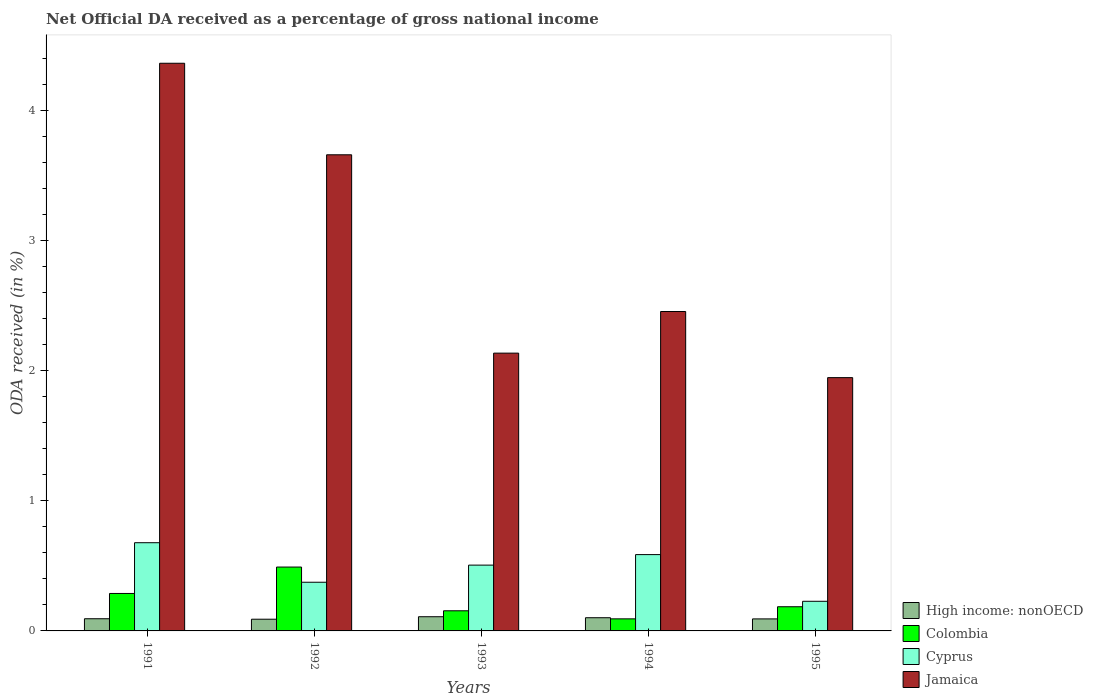How many groups of bars are there?
Ensure brevity in your answer.  5. Are the number of bars on each tick of the X-axis equal?
Your response must be concise. Yes. What is the label of the 5th group of bars from the left?
Your answer should be compact. 1995. What is the net official DA received in Colombia in 1992?
Provide a short and direct response. 0.49. Across all years, what is the maximum net official DA received in Jamaica?
Give a very brief answer. 4.36. Across all years, what is the minimum net official DA received in Colombia?
Your answer should be compact. 0.09. In which year was the net official DA received in Cyprus maximum?
Provide a succinct answer. 1991. What is the total net official DA received in Cyprus in the graph?
Your answer should be very brief. 2.37. What is the difference between the net official DA received in Colombia in 1992 and that in 1993?
Offer a very short reply. 0.34. What is the difference between the net official DA received in High income: nonOECD in 1992 and the net official DA received in Cyprus in 1995?
Your response must be concise. -0.14. What is the average net official DA received in Colombia per year?
Ensure brevity in your answer.  0.24. In the year 1992, what is the difference between the net official DA received in Cyprus and net official DA received in Colombia?
Offer a terse response. -0.12. In how many years, is the net official DA received in High income: nonOECD greater than 3.4 %?
Offer a terse response. 0. What is the ratio of the net official DA received in Colombia in 1992 to that in 1994?
Your response must be concise. 5.29. What is the difference between the highest and the second highest net official DA received in High income: nonOECD?
Offer a terse response. 0.01. What is the difference between the highest and the lowest net official DA received in High income: nonOECD?
Give a very brief answer. 0.02. In how many years, is the net official DA received in High income: nonOECD greater than the average net official DA received in High income: nonOECD taken over all years?
Offer a terse response. 2. Is the sum of the net official DA received in Colombia in 1993 and 1994 greater than the maximum net official DA received in Jamaica across all years?
Your response must be concise. No. What does the 2nd bar from the left in 1995 represents?
Make the answer very short. Colombia. What does the 3rd bar from the right in 1993 represents?
Give a very brief answer. Colombia. Is it the case that in every year, the sum of the net official DA received in Cyprus and net official DA received in Jamaica is greater than the net official DA received in High income: nonOECD?
Give a very brief answer. Yes. How many bars are there?
Ensure brevity in your answer.  20. Are all the bars in the graph horizontal?
Your response must be concise. No. What is the difference between two consecutive major ticks on the Y-axis?
Your response must be concise. 1. Are the values on the major ticks of Y-axis written in scientific E-notation?
Your answer should be very brief. No. How many legend labels are there?
Offer a very short reply. 4. What is the title of the graph?
Your response must be concise. Net Official DA received as a percentage of gross national income. Does "European Union" appear as one of the legend labels in the graph?
Give a very brief answer. No. What is the label or title of the Y-axis?
Your response must be concise. ODA received (in %). What is the ODA received (in %) in High income: nonOECD in 1991?
Your response must be concise. 0.09. What is the ODA received (in %) in Colombia in 1991?
Your response must be concise. 0.29. What is the ODA received (in %) in Cyprus in 1991?
Provide a short and direct response. 0.68. What is the ODA received (in %) of Jamaica in 1991?
Ensure brevity in your answer.  4.36. What is the ODA received (in %) in High income: nonOECD in 1992?
Provide a succinct answer. 0.09. What is the ODA received (in %) of Colombia in 1992?
Provide a succinct answer. 0.49. What is the ODA received (in %) in Cyprus in 1992?
Give a very brief answer. 0.37. What is the ODA received (in %) of Jamaica in 1992?
Keep it short and to the point. 3.66. What is the ODA received (in %) of High income: nonOECD in 1993?
Offer a terse response. 0.11. What is the ODA received (in %) of Colombia in 1993?
Give a very brief answer. 0.15. What is the ODA received (in %) of Cyprus in 1993?
Provide a short and direct response. 0.51. What is the ODA received (in %) in Jamaica in 1993?
Make the answer very short. 2.13. What is the ODA received (in %) of High income: nonOECD in 1994?
Provide a short and direct response. 0.1. What is the ODA received (in %) of Colombia in 1994?
Offer a terse response. 0.09. What is the ODA received (in %) of Cyprus in 1994?
Offer a very short reply. 0.59. What is the ODA received (in %) in Jamaica in 1994?
Your response must be concise. 2.45. What is the ODA received (in %) in High income: nonOECD in 1995?
Your answer should be very brief. 0.09. What is the ODA received (in %) in Colombia in 1995?
Give a very brief answer. 0.19. What is the ODA received (in %) in Cyprus in 1995?
Your answer should be very brief. 0.23. What is the ODA received (in %) in Jamaica in 1995?
Ensure brevity in your answer.  1.95. Across all years, what is the maximum ODA received (in %) of High income: nonOECD?
Offer a terse response. 0.11. Across all years, what is the maximum ODA received (in %) in Colombia?
Provide a succinct answer. 0.49. Across all years, what is the maximum ODA received (in %) of Cyprus?
Your answer should be compact. 0.68. Across all years, what is the maximum ODA received (in %) in Jamaica?
Offer a very short reply. 4.36. Across all years, what is the minimum ODA received (in %) in High income: nonOECD?
Your answer should be compact. 0.09. Across all years, what is the minimum ODA received (in %) of Colombia?
Offer a terse response. 0.09. Across all years, what is the minimum ODA received (in %) of Cyprus?
Your answer should be compact. 0.23. Across all years, what is the minimum ODA received (in %) of Jamaica?
Ensure brevity in your answer.  1.95. What is the total ODA received (in %) in High income: nonOECD in the graph?
Provide a short and direct response. 0.49. What is the total ODA received (in %) in Colombia in the graph?
Offer a very short reply. 1.21. What is the total ODA received (in %) of Cyprus in the graph?
Your answer should be compact. 2.37. What is the total ODA received (in %) in Jamaica in the graph?
Offer a terse response. 14.55. What is the difference between the ODA received (in %) in High income: nonOECD in 1991 and that in 1992?
Ensure brevity in your answer.  0. What is the difference between the ODA received (in %) of Colombia in 1991 and that in 1992?
Give a very brief answer. -0.2. What is the difference between the ODA received (in %) of Cyprus in 1991 and that in 1992?
Give a very brief answer. 0.3. What is the difference between the ODA received (in %) in Jamaica in 1991 and that in 1992?
Your answer should be very brief. 0.7. What is the difference between the ODA received (in %) in High income: nonOECD in 1991 and that in 1993?
Offer a terse response. -0.02. What is the difference between the ODA received (in %) of Colombia in 1991 and that in 1993?
Make the answer very short. 0.13. What is the difference between the ODA received (in %) of Cyprus in 1991 and that in 1993?
Provide a short and direct response. 0.17. What is the difference between the ODA received (in %) in Jamaica in 1991 and that in 1993?
Provide a short and direct response. 2.23. What is the difference between the ODA received (in %) in High income: nonOECD in 1991 and that in 1994?
Give a very brief answer. -0.01. What is the difference between the ODA received (in %) in Colombia in 1991 and that in 1994?
Offer a very short reply. 0.2. What is the difference between the ODA received (in %) of Cyprus in 1991 and that in 1994?
Provide a short and direct response. 0.09. What is the difference between the ODA received (in %) in Jamaica in 1991 and that in 1994?
Make the answer very short. 1.91. What is the difference between the ODA received (in %) in High income: nonOECD in 1991 and that in 1995?
Keep it short and to the point. 0. What is the difference between the ODA received (in %) in Colombia in 1991 and that in 1995?
Make the answer very short. 0.1. What is the difference between the ODA received (in %) in Cyprus in 1991 and that in 1995?
Give a very brief answer. 0.45. What is the difference between the ODA received (in %) in Jamaica in 1991 and that in 1995?
Your answer should be very brief. 2.42. What is the difference between the ODA received (in %) in High income: nonOECD in 1992 and that in 1993?
Provide a short and direct response. -0.02. What is the difference between the ODA received (in %) of Colombia in 1992 and that in 1993?
Provide a succinct answer. 0.34. What is the difference between the ODA received (in %) of Cyprus in 1992 and that in 1993?
Your answer should be very brief. -0.13. What is the difference between the ODA received (in %) of Jamaica in 1992 and that in 1993?
Your response must be concise. 1.52. What is the difference between the ODA received (in %) in High income: nonOECD in 1992 and that in 1994?
Ensure brevity in your answer.  -0.01. What is the difference between the ODA received (in %) in Colombia in 1992 and that in 1994?
Your answer should be very brief. 0.4. What is the difference between the ODA received (in %) of Cyprus in 1992 and that in 1994?
Your response must be concise. -0.21. What is the difference between the ODA received (in %) in Jamaica in 1992 and that in 1994?
Make the answer very short. 1.2. What is the difference between the ODA received (in %) of High income: nonOECD in 1992 and that in 1995?
Ensure brevity in your answer.  -0. What is the difference between the ODA received (in %) of Colombia in 1992 and that in 1995?
Your response must be concise. 0.3. What is the difference between the ODA received (in %) of Cyprus in 1992 and that in 1995?
Offer a terse response. 0.15. What is the difference between the ODA received (in %) of Jamaica in 1992 and that in 1995?
Keep it short and to the point. 1.71. What is the difference between the ODA received (in %) in High income: nonOECD in 1993 and that in 1994?
Offer a very short reply. 0.01. What is the difference between the ODA received (in %) of Colombia in 1993 and that in 1994?
Your response must be concise. 0.06. What is the difference between the ODA received (in %) in Cyprus in 1993 and that in 1994?
Offer a terse response. -0.08. What is the difference between the ODA received (in %) of Jamaica in 1993 and that in 1994?
Provide a short and direct response. -0.32. What is the difference between the ODA received (in %) in High income: nonOECD in 1993 and that in 1995?
Offer a terse response. 0.02. What is the difference between the ODA received (in %) of Colombia in 1993 and that in 1995?
Your answer should be very brief. -0.03. What is the difference between the ODA received (in %) in Cyprus in 1993 and that in 1995?
Provide a short and direct response. 0.28. What is the difference between the ODA received (in %) of Jamaica in 1993 and that in 1995?
Give a very brief answer. 0.19. What is the difference between the ODA received (in %) of High income: nonOECD in 1994 and that in 1995?
Make the answer very short. 0.01. What is the difference between the ODA received (in %) of Colombia in 1994 and that in 1995?
Provide a short and direct response. -0.09. What is the difference between the ODA received (in %) in Cyprus in 1994 and that in 1995?
Your response must be concise. 0.36. What is the difference between the ODA received (in %) in Jamaica in 1994 and that in 1995?
Your answer should be compact. 0.51. What is the difference between the ODA received (in %) of High income: nonOECD in 1991 and the ODA received (in %) of Colombia in 1992?
Keep it short and to the point. -0.4. What is the difference between the ODA received (in %) in High income: nonOECD in 1991 and the ODA received (in %) in Cyprus in 1992?
Give a very brief answer. -0.28. What is the difference between the ODA received (in %) in High income: nonOECD in 1991 and the ODA received (in %) in Jamaica in 1992?
Your answer should be compact. -3.56. What is the difference between the ODA received (in %) of Colombia in 1991 and the ODA received (in %) of Cyprus in 1992?
Your answer should be very brief. -0.09. What is the difference between the ODA received (in %) in Colombia in 1991 and the ODA received (in %) in Jamaica in 1992?
Your answer should be compact. -3.37. What is the difference between the ODA received (in %) of Cyprus in 1991 and the ODA received (in %) of Jamaica in 1992?
Your answer should be compact. -2.98. What is the difference between the ODA received (in %) of High income: nonOECD in 1991 and the ODA received (in %) of Colombia in 1993?
Keep it short and to the point. -0.06. What is the difference between the ODA received (in %) of High income: nonOECD in 1991 and the ODA received (in %) of Cyprus in 1993?
Give a very brief answer. -0.41. What is the difference between the ODA received (in %) of High income: nonOECD in 1991 and the ODA received (in %) of Jamaica in 1993?
Provide a short and direct response. -2.04. What is the difference between the ODA received (in %) in Colombia in 1991 and the ODA received (in %) in Cyprus in 1993?
Make the answer very short. -0.22. What is the difference between the ODA received (in %) in Colombia in 1991 and the ODA received (in %) in Jamaica in 1993?
Your answer should be compact. -1.85. What is the difference between the ODA received (in %) in Cyprus in 1991 and the ODA received (in %) in Jamaica in 1993?
Your answer should be compact. -1.46. What is the difference between the ODA received (in %) of High income: nonOECD in 1991 and the ODA received (in %) of Colombia in 1994?
Provide a succinct answer. 0. What is the difference between the ODA received (in %) of High income: nonOECD in 1991 and the ODA received (in %) of Cyprus in 1994?
Your response must be concise. -0.49. What is the difference between the ODA received (in %) of High income: nonOECD in 1991 and the ODA received (in %) of Jamaica in 1994?
Provide a short and direct response. -2.36. What is the difference between the ODA received (in %) in Colombia in 1991 and the ODA received (in %) in Cyprus in 1994?
Your response must be concise. -0.3. What is the difference between the ODA received (in %) of Colombia in 1991 and the ODA received (in %) of Jamaica in 1994?
Keep it short and to the point. -2.17. What is the difference between the ODA received (in %) in Cyprus in 1991 and the ODA received (in %) in Jamaica in 1994?
Ensure brevity in your answer.  -1.78. What is the difference between the ODA received (in %) in High income: nonOECD in 1991 and the ODA received (in %) in Colombia in 1995?
Provide a short and direct response. -0.09. What is the difference between the ODA received (in %) of High income: nonOECD in 1991 and the ODA received (in %) of Cyprus in 1995?
Keep it short and to the point. -0.13. What is the difference between the ODA received (in %) of High income: nonOECD in 1991 and the ODA received (in %) of Jamaica in 1995?
Offer a very short reply. -1.85. What is the difference between the ODA received (in %) in Colombia in 1991 and the ODA received (in %) in Cyprus in 1995?
Your answer should be compact. 0.06. What is the difference between the ODA received (in %) of Colombia in 1991 and the ODA received (in %) of Jamaica in 1995?
Your response must be concise. -1.66. What is the difference between the ODA received (in %) of Cyprus in 1991 and the ODA received (in %) of Jamaica in 1995?
Offer a very short reply. -1.27. What is the difference between the ODA received (in %) of High income: nonOECD in 1992 and the ODA received (in %) of Colombia in 1993?
Provide a short and direct response. -0.06. What is the difference between the ODA received (in %) in High income: nonOECD in 1992 and the ODA received (in %) in Cyprus in 1993?
Ensure brevity in your answer.  -0.42. What is the difference between the ODA received (in %) of High income: nonOECD in 1992 and the ODA received (in %) of Jamaica in 1993?
Keep it short and to the point. -2.04. What is the difference between the ODA received (in %) in Colombia in 1992 and the ODA received (in %) in Cyprus in 1993?
Your answer should be compact. -0.01. What is the difference between the ODA received (in %) of Colombia in 1992 and the ODA received (in %) of Jamaica in 1993?
Ensure brevity in your answer.  -1.64. What is the difference between the ODA received (in %) of Cyprus in 1992 and the ODA received (in %) of Jamaica in 1993?
Your answer should be compact. -1.76. What is the difference between the ODA received (in %) of High income: nonOECD in 1992 and the ODA received (in %) of Colombia in 1994?
Provide a succinct answer. -0. What is the difference between the ODA received (in %) of High income: nonOECD in 1992 and the ODA received (in %) of Cyprus in 1994?
Provide a short and direct response. -0.5. What is the difference between the ODA received (in %) in High income: nonOECD in 1992 and the ODA received (in %) in Jamaica in 1994?
Keep it short and to the point. -2.36. What is the difference between the ODA received (in %) in Colombia in 1992 and the ODA received (in %) in Cyprus in 1994?
Offer a very short reply. -0.1. What is the difference between the ODA received (in %) in Colombia in 1992 and the ODA received (in %) in Jamaica in 1994?
Give a very brief answer. -1.96. What is the difference between the ODA received (in %) of Cyprus in 1992 and the ODA received (in %) of Jamaica in 1994?
Offer a very short reply. -2.08. What is the difference between the ODA received (in %) in High income: nonOECD in 1992 and the ODA received (in %) in Colombia in 1995?
Provide a succinct answer. -0.1. What is the difference between the ODA received (in %) in High income: nonOECD in 1992 and the ODA received (in %) in Cyprus in 1995?
Your answer should be compact. -0.14. What is the difference between the ODA received (in %) of High income: nonOECD in 1992 and the ODA received (in %) of Jamaica in 1995?
Your response must be concise. -1.86. What is the difference between the ODA received (in %) in Colombia in 1992 and the ODA received (in %) in Cyprus in 1995?
Offer a terse response. 0.26. What is the difference between the ODA received (in %) in Colombia in 1992 and the ODA received (in %) in Jamaica in 1995?
Offer a terse response. -1.46. What is the difference between the ODA received (in %) of Cyprus in 1992 and the ODA received (in %) of Jamaica in 1995?
Your response must be concise. -1.57. What is the difference between the ODA received (in %) in High income: nonOECD in 1993 and the ODA received (in %) in Colombia in 1994?
Provide a succinct answer. 0.02. What is the difference between the ODA received (in %) of High income: nonOECD in 1993 and the ODA received (in %) of Cyprus in 1994?
Keep it short and to the point. -0.48. What is the difference between the ODA received (in %) of High income: nonOECD in 1993 and the ODA received (in %) of Jamaica in 1994?
Ensure brevity in your answer.  -2.34. What is the difference between the ODA received (in %) in Colombia in 1993 and the ODA received (in %) in Cyprus in 1994?
Keep it short and to the point. -0.43. What is the difference between the ODA received (in %) of Colombia in 1993 and the ODA received (in %) of Jamaica in 1994?
Provide a short and direct response. -2.3. What is the difference between the ODA received (in %) in Cyprus in 1993 and the ODA received (in %) in Jamaica in 1994?
Provide a short and direct response. -1.95. What is the difference between the ODA received (in %) in High income: nonOECD in 1993 and the ODA received (in %) in Colombia in 1995?
Offer a terse response. -0.08. What is the difference between the ODA received (in %) of High income: nonOECD in 1993 and the ODA received (in %) of Cyprus in 1995?
Your answer should be very brief. -0.12. What is the difference between the ODA received (in %) in High income: nonOECD in 1993 and the ODA received (in %) in Jamaica in 1995?
Offer a terse response. -1.84. What is the difference between the ODA received (in %) of Colombia in 1993 and the ODA received (in %) of Cyprus in 1995?
Make the answer very short. -0.07. What is the difference between the ODA received (in %) of Colombia in 1993 and the ODA received (in %) of Jamaica in 1995?
Offer a terse response. -1.79. What is the difference between the ODA received (in %) in Cyprus in 1993 and the ODA received (in %) in Jamaica in 1995?
Your response must be concise. -1.44. What is the difference between the ODA received (in %) of High income: nonOECD in 1994 and the ODA received (in %) of Colombia in 1995?
Offer a terse response. -0.08. What is the difference between the ODA received (in %) in High income: nonOECD in 1994 and the ODA received (in %) in Cyprus in 1995?
Offer a very short reply. -0.13. What is the difference between the ODA received (in %) of High income: nonOECD in 1994 and the ODA received (in %) of Jamaica in 1995?
Provide a short and direct response. -1.84. What is the difference between the ODA received (in %) in Colombia in 1994 and the ODA received (in %) in Cyprus in 1995?
Offer a very short reply. -0.14. What is the difference between the ODA received (in %) of Colombia in 1994 and the ODA received (in %) of Jamaica in 1995?
Offer a very short reply. -1.85. What is the difference between the ODA received (in %) of Cyprus in 1994 and the ODA received (in %) of Jamaica in 1995?
Provide a succinct answer. -1.36. What is the average ODA received (in %) of High income: nonOECD per year?
Offer a very short reply. 0.1. What is the average ODA received (in %) in Colombia per year?
Offer a very short reply. 0.24. What is the average ODA received (in %) of Cyprus per year?
Ensure brevity in your answer.  0.47. What is the average ODA received (in %) in Jamaica per year?
Ensure brevity in your answer.  2.91. In the year 1991, what is the difference between the ODA received (in %) in High income: nonOECD and ODA received (in %) in Colombia?
Provide a succinct answer. -0.19. In the year 1991, what is the difference between the ODA received (in %) in High income: nonOECD and ODA received (in %) in Cyprus?
Ensure brevity in your answer.  -0.58. In the year 1991, what is the difference between the ODA received (in %) in High income: nonOECD and ODA received (in %) in Jamaica?
Offer a terse response. -4.27. In the year 1991, what is the difference between the ODA received (in %) in Colombia and ODA received (in %) in Cyprus?
Provide a short and direct response. -0.39. In the year 1991, what is the difference between the ODA received (in %) in Colombia and ODA received (in %) in Jamaica?
Provide a succinct answer. -4.07. In the year 1991, what is the difference between the ODA received (in %) of Cyprus and ODA received (in %) of Jamaica?
Make the answer very short. -3.68. In the year 1992, what is the difference between the ODA received (in %) in High income: nonOECD and ODA received (in %) in Colombia?
Provide a short and direct response. -0.4. In the year 1992, what is the difference between the ODA received (in %) of High income: nonOECD and ODA received (in %) of Cyprus?
Your answer should be very brief. -0.28. In the year 1992, what is the difference between the ODA received (in %) of High income: nonOECD and ODA received (in %) of Jamaica?
Ensure brevity in your answer.  -3.57. In the year 1992, what is the difference between the ODA received (in %) of Colombia and ODA received (in %) of Cyprus?
Give a very brief answer. 0.12. In the year 1992, what is the difference between the ODA received (in %) of Colombia and ODA received (in %) of Jamaica?
Offer a terse response. -3.17. In the year 1992, what is the difference between the ODA received (in %) in Cyprus and ODA received (in %) in Jamaica?
Your response must be concise. -3.28. In the year 1993, what is the difference between the ODA received (in %) in High income: nonOECD and ODA received (in %) in Colombia?
Your response must be concise. -0.05. In the year 1993, what is the difference between the ODA received (in %) of High income: nonOECD and ODA received (in %) of Cyprus?
Offer a terse response. -0.4. In the year 1993, what is the difference between the ODA received (in %) in High income: nonOECD and ODA received (in %) in Jamaica?
Offer a terse response. -2.03. In the year 1993, what is the difference between the ODA received (in %) in Colombia and ODA received (in %) in Cyprus?
Keep it short and to the point. -0.35. In the year 1993, what is the difference between the ODA received (in %) of Colombia and ODA received (in %) of Jamaica?
Keep it short and to the point. -1.98. In the year 1993, what is the difference between the ODA received (in %) in Cyprus and ODA received (in %) in Jamaica?
Provide a succinct answer. -1.63. In the year 1994, what is the difference between the ODA received (in %) in High income: nonOECD and ODA received (in %) in Colombia?
Your response must be concise. 0.01. In the year 1994, what is the difference between the ODA received (in %) in High income: nonOECD and ODA received (in %) in Cyprus?
Provide a succinct answer. -0.48. In the year 1994, what is the difference between the ODA received (in %) of High income: nonOECD and ODA received (in %) of Jamaica?
Make the answer very short. -2.35. In the year 1994, what is the difference between the ODA received (in %) of Colombia and ODA received (in %) of Cyprus?
Make the answer very short. -0.49. In the year 1994, what is the difference between the ODA received (in %) in Colombia and ODA received (in %) in Jamaica?
Your answer should be compact. -2.36. In the year 1994, what is the difference between the ODA received (in %) in Cyprus and ODA received (in %) in Jamaica?
Your response must be concise. -1.87. In the year 1995, what is the difference between the ODA received (in %) in High income: nonOECD and ODA received (in %) in Colombia?
Your response must be concise. -0.09. In the year 1995, what is the difference between the ODA received (in %) of High income: nonOECD and ODA received (in %) of Cyprus?
Offer a very short reply. -0.14. In the year 1995, what is the difference between the ODA received (in %) of High income: nonOECD and ODA received (in %) of Jamaica?
Your response must be concise. -1.85. In the year 1995, what is the difference between the ODA received (in %) in Colombia and ODA received (in %) in Cyprus?
Your response must be concise. -0.04. In the year 1995, what is the difference between the ODA received (in %) in Colombia and ODA received (in %) in Jamaica?
Offer a terse response. -1.76. In the year 1995, what is the difference between the ODA received (in %) of Cyprus and ODA received (in %) of Jamaica?
Keep it short and to the point. -1.72. What is the ratio of the ODA received (in %) in High income: nonOECD in 1991 to that in 1992?
Keep it short and to the point. 1.04. What is the ratio of the ODA received (in %) in Colombia in 1991 to that in 1992?
Your response must be concise. 0.59. What is the ratio of the ODA received (in %) in Cyprus in 1991 to that in 1992?
Make the answer very short. 1.81. What is the ratio of the ODA received (in %) in Jamaica in 1991 to that in 1992?
Your answer should be compact. 1.19. What is the ratio of the ODA received (in %) in High income: nonOECD in 1991 to that in 1993?
Provide a short and direct response. 0.86. What is the ratio of the ODA received (in %) in Colombia in 1991 to that in 1993?
Your response must be concise. 1.86. What is the ratio of the ODA received (in %) in Cyprus in 1991 to that in 1993?
Offer a terse response. 1.34. What is the ratio of the ODA received (in %) in Jamaica in 1991 to that in 1993?
Make the answer very short. 2.04. What is the ratio of the ODA received (in %) in High income: nonOECD in 1991 to that in 1994?
Give a very brief answer. 0.92. What is the ratio of the ODA received (in %) in Colombia in 1991 to that in 1994?
Provide a short and direct response. 3.1. What is the ratio of the ODA received (in %) of Cyprus in 1991 to that in 1994?
Your response must be concise. 1.16. What is the ratio of the ODA received (in %) of Jamaica in 1991 to that in 1994?
Offer a very short reply. 1.78. What is the ratio of the ODA received (in %) in High income: nonOECD in 1991 to that in 1995?
Offer a terse response. 1.01. What is the ratio of the ODA received (in %) of Colombia in 1991 to that in 1995?
Provide a succinct answer. 1.55. What is the ratio of the ODA received (in %) of Cyprus in 1991 to that in 1995?
Your response must be concise. 2.98. What is the ratio of the ODA received (in %) in Jamaica in 1991 to that in 1995?
Your response must be concise. 2.24. What is the ratio of the ODA received (in %) of High income: nonOECD in 1992 to that in 1993?
Provide a short and direct response. 0.83. What is the ratio of the ODA received (in %) in Colombia in 1992 to that in 1993?
Provide a short and direct response. 3.17. What is the ratio of the ODA received (in %) in Cyprus in 1992 to that in 1993?
Your response must be concise. 0.74. What is the ratio of the ODA received (in %) of Jamaica in 1992 to that in 1993?
Provide a succinct answer. 1.71. What is the ratio of the ODA received (in %) in High income: nonOECD in 1992 to that in 1994?
Give a very brief answer. 0.89. What is the ratio of the ODA received (in %) of Colombia in 1992 to that in 1994?
Offer a terse response. 5.29. What is the ratio of the ODA received (in %) of Cyprus in 1992 to that in 1994?
Your response must be concise. 0.64. What is the ratio of the ODA received (in %) in Jamaica in 1992 to that in 1994?
Give a very brief answer. 1.49. What is the ratio of the ODA received (in %) of High income: nonOECD in 1992 to that in 1995?
Your answer should be compact. 0.97. What is the ratio of the ODA received (in %) of Colombia in 1992 to that in 1995?
Your answer should be very brief. 2.64. What is the ratio of the ODA received (in %) in Cyprus in 1992 to that in 1995?
Keep it short and to the point. 1.64. What is the ratio of the ODA received (in %) in Jamaica in 1992 to that in 1995?
Provide a succinct answer. 1.88. What is the ratio of the ODA received (in %) of High income: nonOECD in 1993 to that in 1994?
Offer a terse response. 1.08. What is the ratio of the ODA received (in %) of Colombia in 1993 to that in 1994?
Your response must be concise. 1.67. What is the ratio of the ODA received (in %) in Cyprus in 1993 to that in 1994?
Provide a succinct answer. 0.86. What is the ratio of the ODA received (in %) of Jamaica in 1993 to that in 1994?
Your answer should be very brief. 0.87. What is the ratio of the ODA received (in %) in High income: nonOECD in 1993 to that in 1995?
Make the answer very short. 1.18. What is the ratio of the ODA received (in %) of Colombia in 1993 to that in 1995?
Offer a very short reply. 0.83. What is the ratio of the ODA received (in %) in Cyprus in 1993 to that in 1995?
Your answer should be compact. 2.22. What is the ratio of the ODA received (in %) in Jamaica in 1993 to that in 1995?
Make the answer very short. 1.1. What is the ratio of the ODA received (in %) of High income: nonOECD in 1994 to that in 1995?
Your answer should be very brief. 1.1. What is the ratio of the ODA received (in %) in Colombia in 1994 to that in 1995?
Offer a terse response. 0.5. What is the ratio of the ODA received (in %) of Cyprus in 1994 to that in 1995?
Give a very brief answer. 2.58. What is the ratio of the ODA received (in %) of Jamaica in 1994 to that in 1995?
Make the answer very short. 1.26. What is the difference between the highest and the second highest ODA received (in %) of High income: nonOECD?
Ensure brevity in your answer.  0.01. What is the difference between the highest and the second highest ODA received (in %) in Colombia?
Your response must be concise. 0.2. What is the difference between the highest and the second highest ODA received (in %) of Cyprus?
Make the answer very short. 0.09. What is the difference between the highest and the second highest ODA received (in %) of Jamaica?
Give a very brief answer. 0.7. What is the difference between the highest and the lowest ODA received (in %) of High income: nonOECD?
Make the answer very short. 0.02. What is the difference between the highest and the lowest ODA received (in %) in Colombia?
Provide a succinct answer. 0.4. What is the difference between the highest and the lowest ODA received (in %) in Cyprus?
Keep it short and to the point. 0.45. What is the difference between the highest and the lowest ODA received (in %) of Jamaica?
Keep it short and to the point. 2.42. 